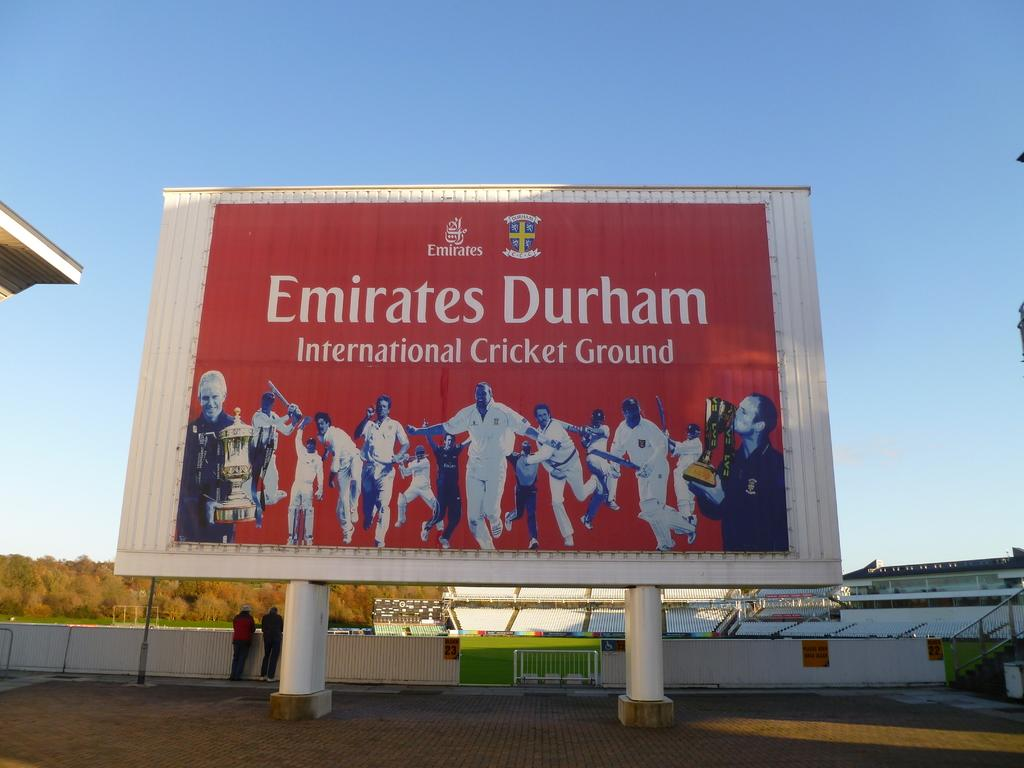Provide a one-sentence caption for the provided image. a billboard with a group of cricket players featured on it. 